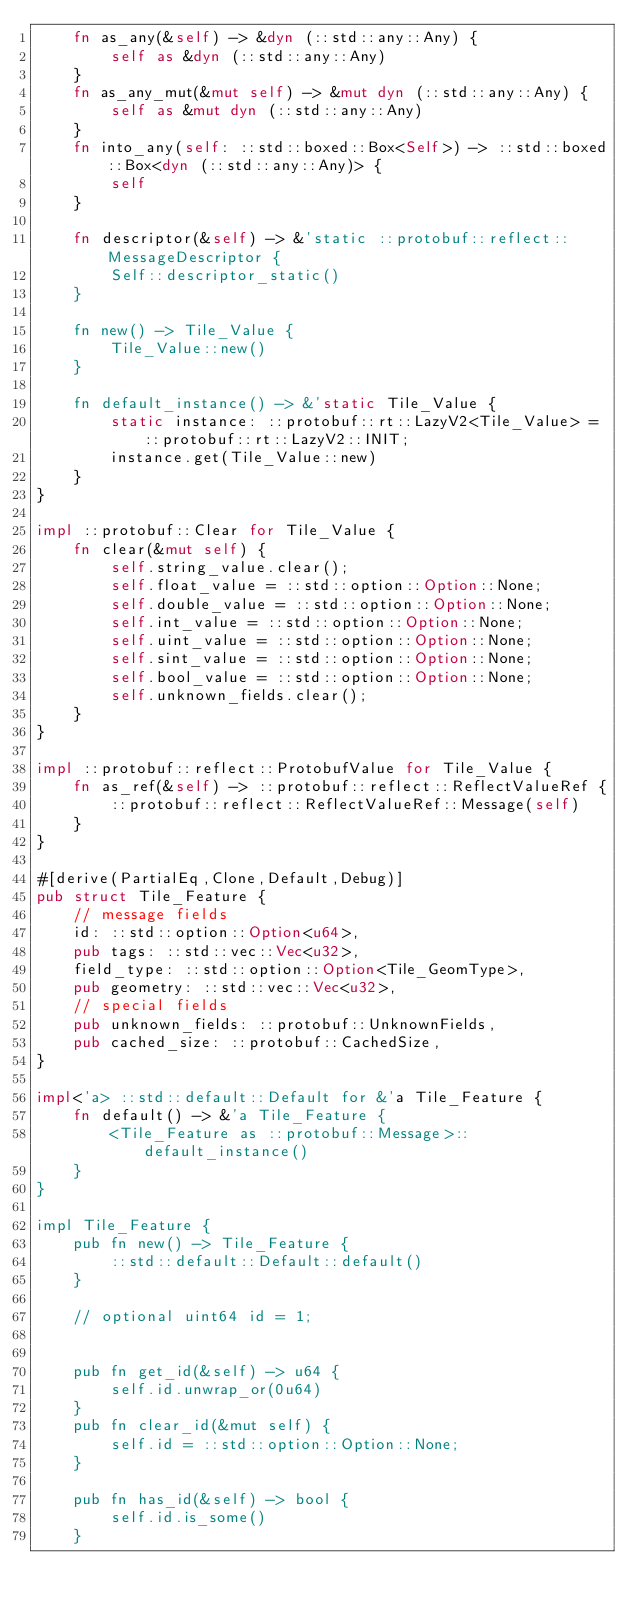<code> <loc_0><loc_0><loc_500><loc_500><_Rust_>    fn as_any(&self) -> &dyn (::std::any::Any) {
        self as &dyn (::std::any::Any)
    }
    fn as_any_mut(&mut self) -> &mut dyn (::std::any::Any) {
        self as &mut dyn (::std::any::Any)
    }
    fn into_any(self: ::std::boxed::Box<Self>) -> ::std::boxed::Box<dyn (::std::any::Any)> {
        self
    }

    fn descriptor(&self) -> &'static ::protobuf::reflect::MessageDescriptor {
        Self::descriptor_static()
    }

    fn new() -> Tile_Value {
        Tile_Value::new()
    }

    fn default_instance() -> &'static Tile_Value {
        static instance: ::protobuf::rt::LazyV2<Tile_Value> = ::protobuf::rt::LazyV2::INIT;
        instance.get(Tile_Value::new)
    }
}

impl ::protobuf::Clear for Tile_Value {
    fn clear(&mut self) {
        self.string_value.clear();
        self.float_value = ::std::option::Option::None;
        self.double_value = ::std::option::Option::None;
        self.int_value = ::std::option::Option::None;
        self.uint_value = ::std::option::Option::None;
        self.sint_value = ::std::option::Option::None;
        self.bool_value = ::std::option::Option::None;
        self.unknown_fields.clear();
    }
}

impl ::protobuf::reflect::ProtobufValue for Tile_Value {
    fn as_ref(&self) -> ::protobuf::reflect::ReflectValueRef {
        ::protobuf::reflect::ReflectValueRef::Message(self)
    }
}

#[derive(PartialEq,Clone,Default,Debug)]
pub struct Tile_Feature {
    // message fields
    id: ::std::option::Option<u64>,
    pub tags: ::std::vec::Vec<u32>,
    field_type: ::std::option::Option<Tile_GeomType>,
    pub geometry: ::std::vec::Vec<u32>,
    // special fields
    pub unknown_fields: ::protobuf::UnknownFields,
    pub cached_size: ::protobuf::CachedSize,
}

impl<'a> ::std::default::Default for &'a Tile_Feature {
    fn default() -> &'a Tile_Feature {
        <Tile_Feature as ::protobuf::Message>::default_instance()
    }
}

impl Tile_Feature {
    pub fn new() -> Tile_Feature {
        ::std::default::Default::default()
    }

    // optional uint64 id = 1;


    pub fn get_id(&self) -> u64 {
        self.id.unwrap_or(0u64)
    }
    pub fn clear_id(&mut self) {
        self.id = ::std::option::Option::None;
    }

    pub fn has_id(&self) -> bool {
        self.id.is_some()
    }
</code> 